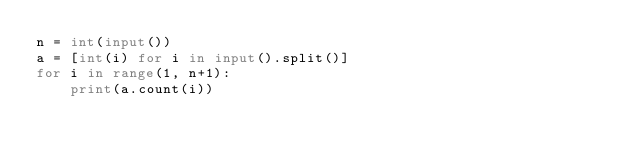Convert code to text. <code><loc_0><loc_0><loc_500><loc_500><_Python_>n = int(input())
a = [int(i) for i in input().split()]
for i in range(1, n+1):
    print(a.count(i))</code> 